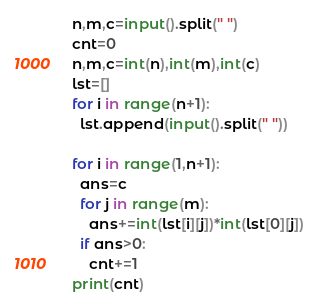Convert code to text. <code><loc_0><loc_0><loc_500><loc_500><_Python_>n,m,c=input().split(" ")
cnt=0
n,m,c=int(n),int(m),int(c)
lst=[]
for i in range(n+1):
  lst.append(input().split(" "))

for i in range(1,n+1):
  ans=c
  for j in range(m):
    ans+=int(lst[i][j])*int(lst[0][j])
  if ans>0:
    cnt+=1
print(cnt)</code> 